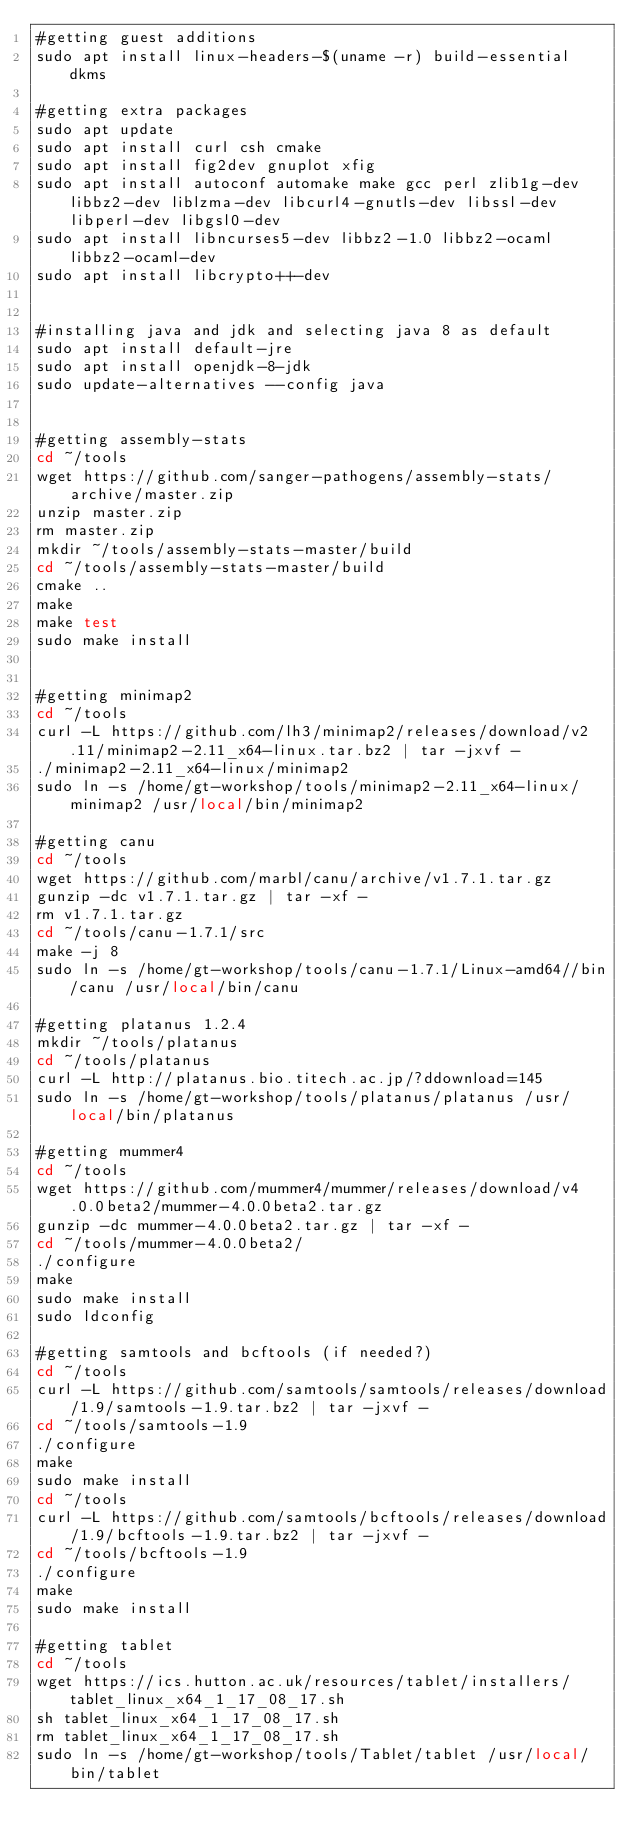<code> <loc_0><loc_0><loc_500><loc_500><_Bash_>#getting guest additions
sudo apt install linux-headers-$(uname -r) build-essential dkms

#getting extra packages
sudo apt update
sudo apt install curl csh cmake
sudo apt install fig2dev gnuplot xfig
sudo apt install autoconf automake make gcc perl zlib1g-dev libbz2-dev liblzma-dev libcurl4-gnutls-dev libssl-dev libperl-dev libgsl0-dev
sudo apt install libncurses5-dev libbz2-1.0 libbz2-ocaml libbz2-ocaml-dev 
sudo apt install libcrypto++-dev


#installing java and jdk and selecting java 8 as default
sudo apt install default-jre
sudo apt install openjdk-8-jdk
sudo update-alternatives --config java


#getting assembly-stats
cd ~/tools
wget https://github.com/sanger-pathogens/assembly-stats/archive/master.zip 
unzip master.zip 
rm master.zip
mkdir ~/tools/assembly-stats-master/build
cd ~/tools/assembly-stats-master/build
cmake ..
make
make test
sudo make install


#getting minimap2
cd ~/tools
curl -L https://github.com/lh3/minimap2/releases/download/v2.11/minimap2-2.11_x64-linux.tar.bz2 | tar -jxvf -
./minimap2-2.11_x64-linux/minimap2
sudo ln -s /home/gt-workshop/tools/minimap2-2.11_x64-linux/minimap2 /usr/local/bin/minimap2

#getting canu
cd ~/tools
wget https://github.com/marbl/canu/archive/v1.7.1.tar.gz
gunzip -dc v1.7.1.tar.gz | tar -xf -
rm v1.7.1.tar.gz
cd ~/tools/canu-1.7.1/src
make -j 8
sudo ln -s /home/gt-workshop/tools/canu-1.7.1/Linux-amd64//bin/canu /usr/local/bin/canu

#getting platanus 1.2.4
mkdir ~/tools/platanus
cd ~/tools/platanus
curl -L http://platanus.bio.titech.ac.jp/?ddownload=145
sudo ln -s /home/gt-workshop/tools/platanus/platanus /usr/local/bin/platanus

#getting mummer4
cd ~/tools
wget https://github.com/mummer4/mummer/releases/download/v4.0.0beta2/mummer-4.0.0beta2.tar.gz
gunzip -dc mummer-4.0.0beta2.tar.gz | tar -xf -
cd ~/tools/mummer-4.0.0beta2/
./configure 
make
sudo make install
sudo ldconfig

#getting samtools and bcftools (if needed?)
cd ~/tools
curl -L https://github.com/samtools/samtools/releases/download/1.9/samtools-1.9.tar.bz2 | tar -jxvf -
cd ~/tools/samtools-1.9
./configure
make
sudo make install
cd ~/tools
curl -L https://github.com/samtools/bcftools/releases/download/1.9/bcftools-1.9.tar.bz2 | tar -jxvf -
cd ~/tools/bcftools-1.9
./configure
make
sudo make install

#getting tablet
cd ~/tools
wget https://ics.hutton.ac.uk/resources/tablet/installers/tablet_linux_x64_1_17_08_17.sh
sh tablet_linux_x64_1_17_08_17.sh
rm tablet_linux_x64_1_17_08_17.sh
sudo ln -s /home/gt-workshop/tools/Tablet/tablet /usr/local/bin/tablet

</code> 